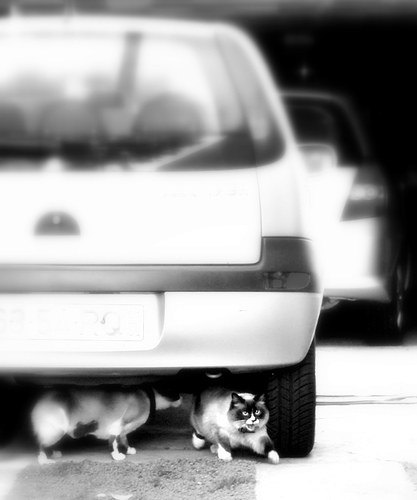Can you infer anything about the time of day or weather from the image? The lighting in the image isn't very strong; however, the lack of deep shadows suggests it might be an overcast day or possibly the sun is not at its peak height, which could be morning or late afternoon. Are the cats in any immediate danger? There's no immediate danger visible in the image, but cats under cars can be at risk if the car moves suddenly without the driver noticing them. 